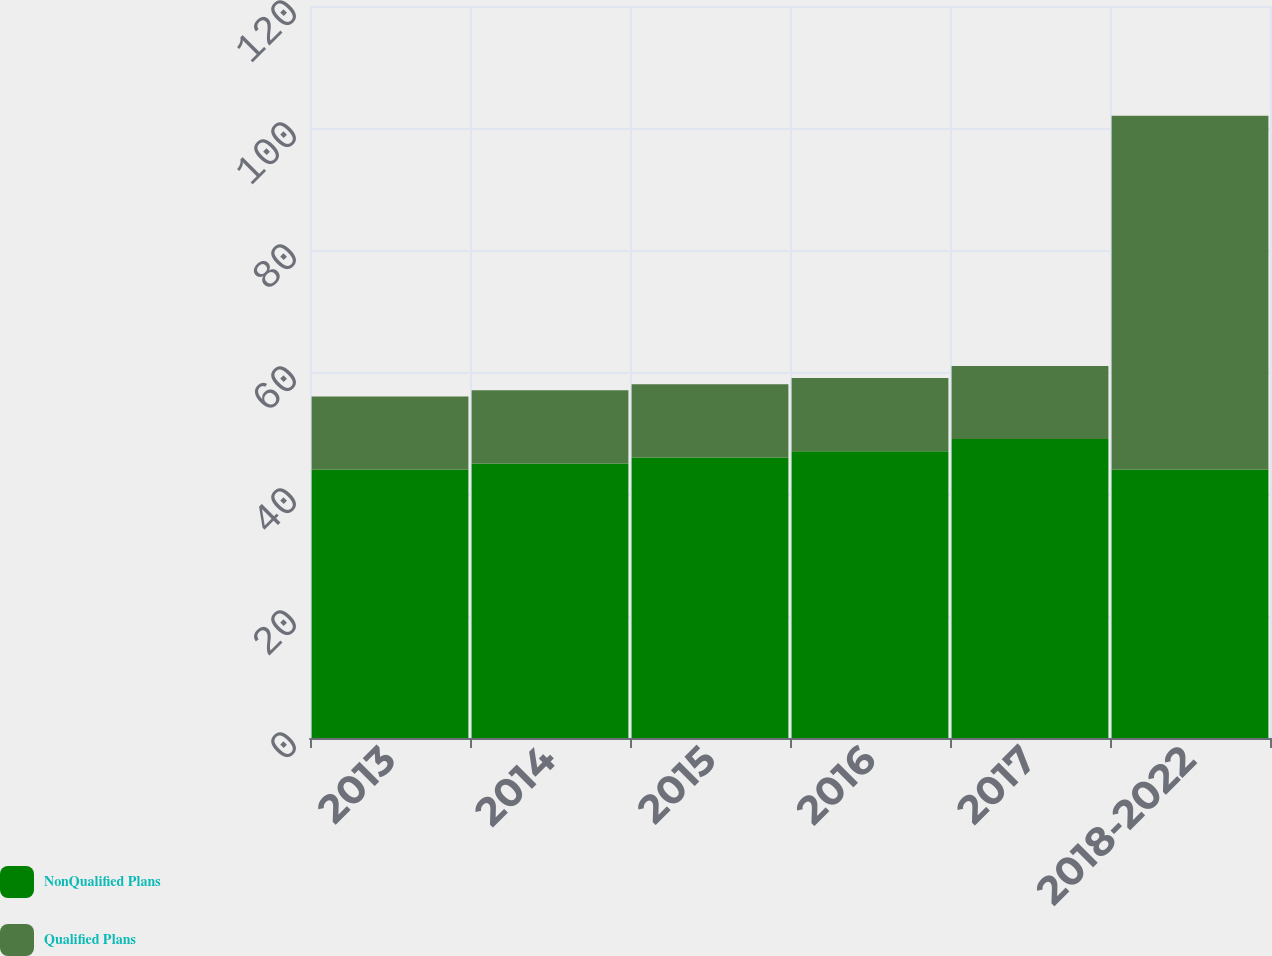<chart> <loc_0><loc_0><loc_500><loc_500><stacked_bar_chart><ecel><fcel>2013<fcel>2014<fcel>2015<fcel>2016<fcel>2017<fcel>2018-2022<nl><fcel>NonQualified Plans<fcel>44<fcel>45<fcel>46<fcel>47<fcel>49<fcel>44<nl><fcel>Qualified Plans<fcel>12<fcel>12<fcel>12<fcel>12<fcel>12<fcel>58<nl></chart> 